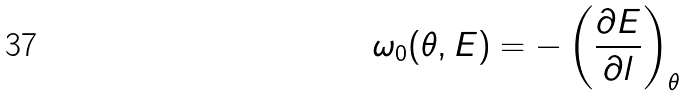<formula> <loc_0><loc_0><loc_500><loc_500>\omega _ { 0 } ( \theta , E ) = - \left ( \frac { \partial E } { \partial l } \right ) _ { \theta }</formula> 